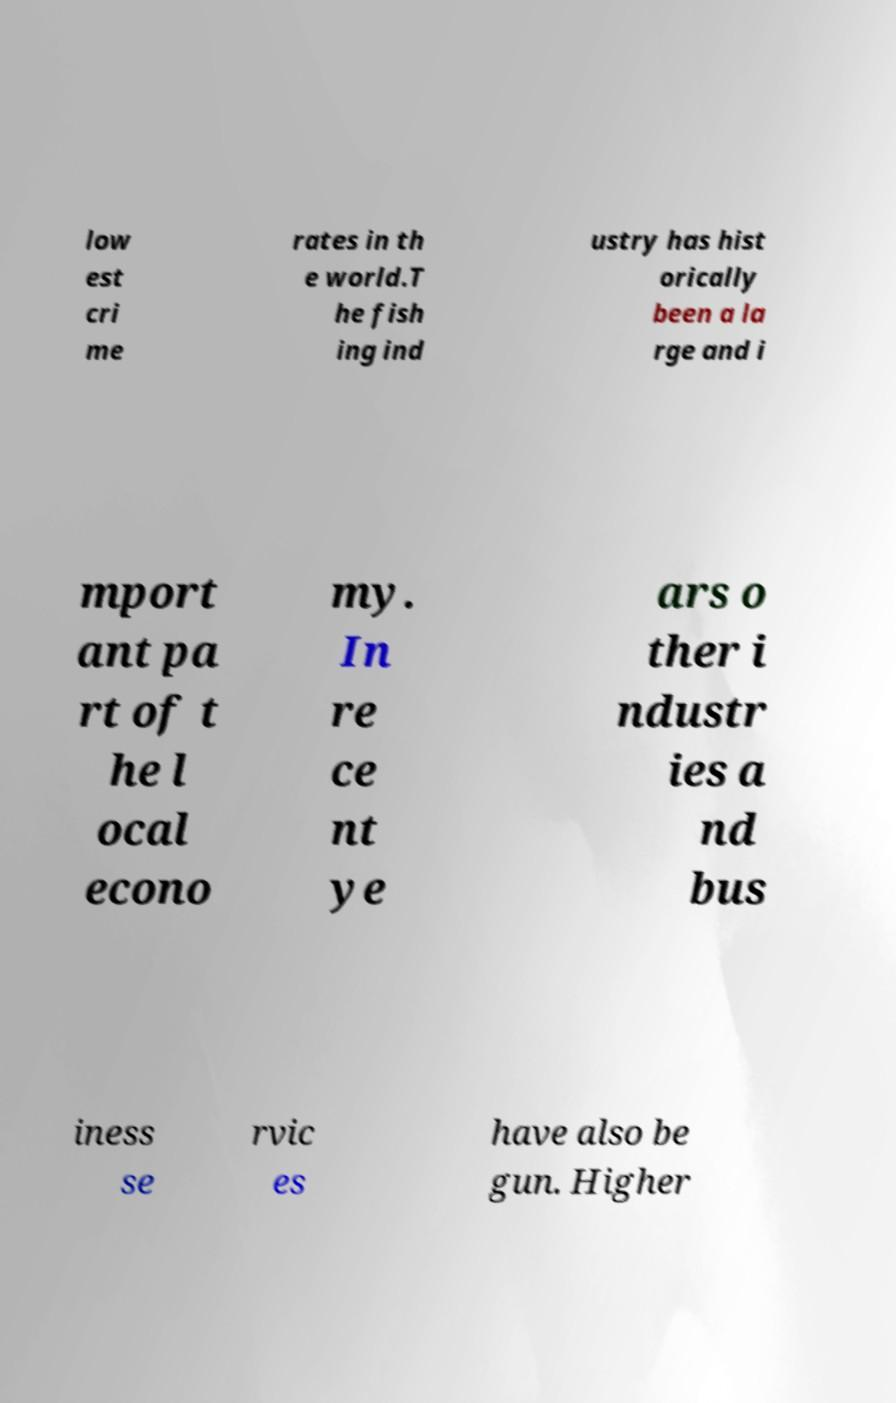I need the written content from this picture converted into text. Can you do that? low est cri me rates in th e world.T he fish ing ind ustry has hist orically been a la rge and i mport ant pa rt of t he l ocal econo my. In re ce nt ye ars o ther i ndustr ies a nd bus iness se rvic es have also be gun. Higher 